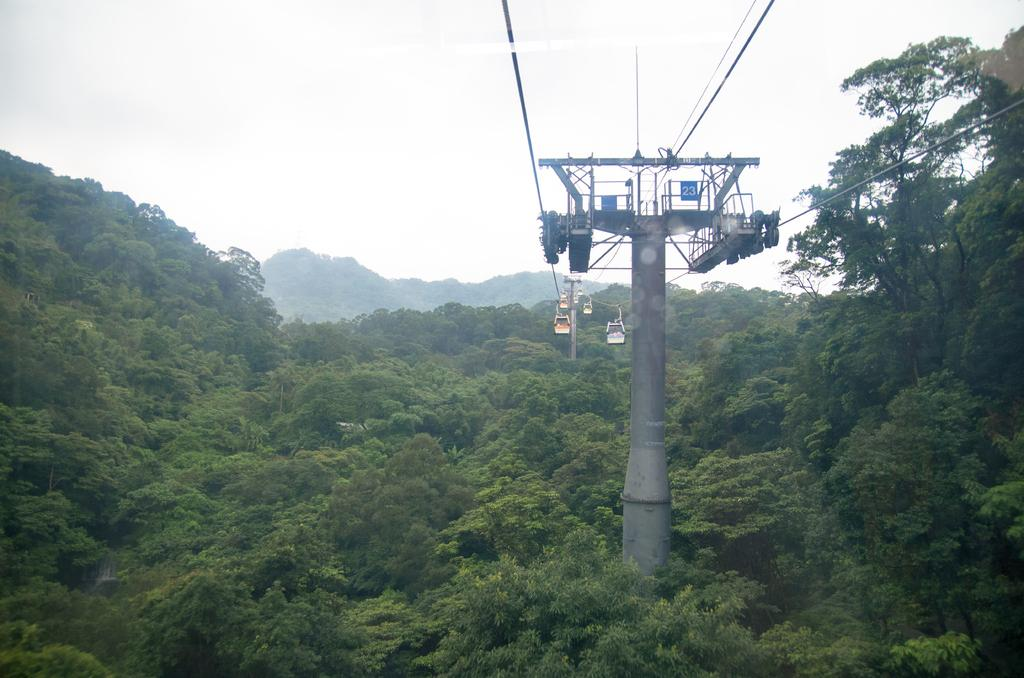What type of natural environment is depicted in the image? There is a forest in the image. What can be found in the middle of the forest? There is a pole in the middle of the forest. What is attached to the pole? Wires are attached to the pole. What is the color of the sky in the image? The sky is white in color. What type of zinc object can be seen on the ground in the image? There is no zinc object present on the ground in the image. What type of crack is visible on the pole in the image? There is no crack visible on the pole in the image. 